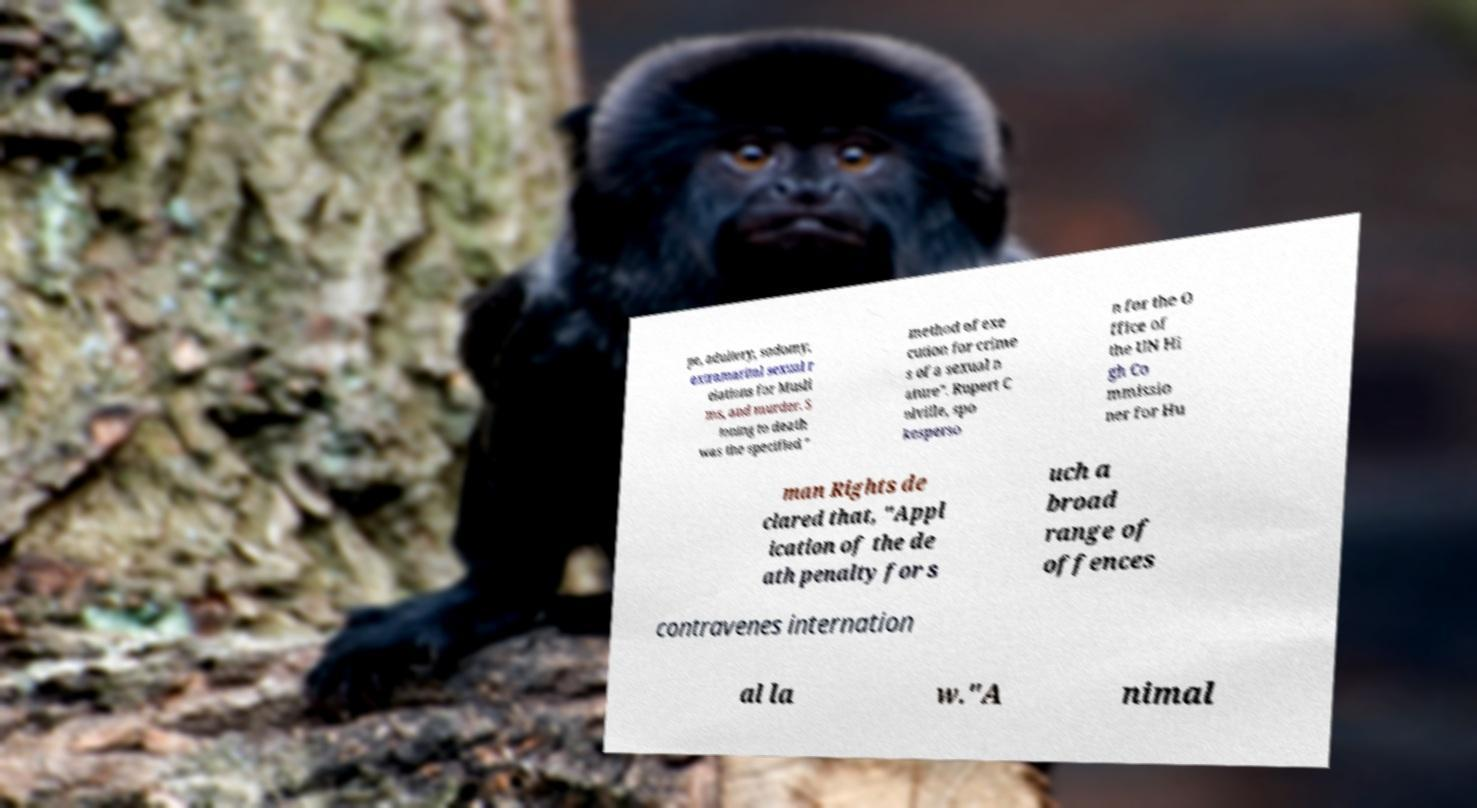Can you read and provide the text displayed in the image?This photo seems to have some interesting text. Can you extract and type it out for me? pe, adultery, sodomy, extramarital sexual r elations for Musli ms, and murder. S toning to death was the specified " method of exe cution for crime s of a sexual n ature". Rupert C olville, spo kesperso n for the O ffice of the UN Hi gh Co mmissio ner for Hu man Rights de clared that, "Appl ication of the de ath penalty for s uch a broad range of offences contravenes internation al la w."A nimal 